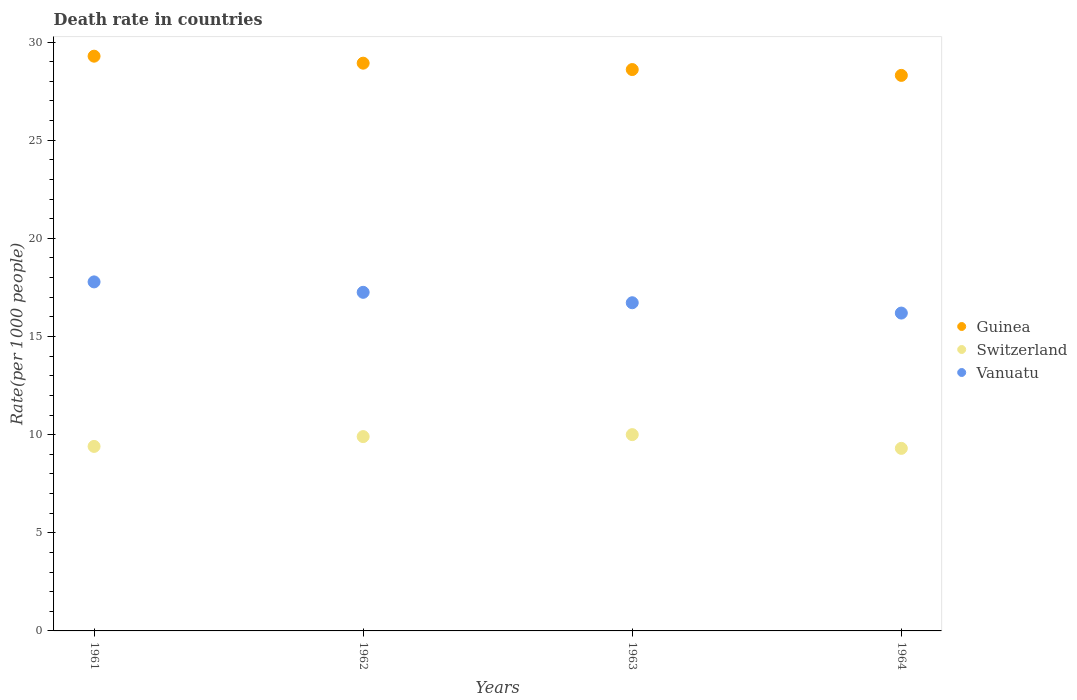How many different coloured dotlines are there?
Your answer should be very brief. 3. Is the number of dotlines equal to the number of legend labels?
Offer a very short reply. Yes. What is the death rate in Guinea in 1963?
Offer a terse response. 28.6. Across all years, what is the maximum death rate in Switzerland?
Your answer should be very brief. 10. Across all years, what is the minimum death rate in Guinea?
Your response must be concise. 28.3. In which year was the death rate in Vanuatu minimum?
Ensure brevity in your answer.  1964. What is the total death rate in Vanuatu in the graph?
Provide a succinct answer. 67.94. What is the difference between the death rate in Switzerland in 1961 and that in 1962?
Make the answer very short. -0.5. What is the difference between the death rate in Vanuatu in 1961 and the death rate in Switzerland in 1963?
Your answer should be very brief. 7.78. What is the average death rate in Guinea per year?
Make the answer very short. 28.78. In the year 1962, what is the difference between the death rate in Guinea and death rate in Vanuatu?
Offer a terse response. 11.67. In how many years, is the death rate in Guinea greater than 3?
Offer a very short reply. 4. What is the ratio of the death rate in Vanuatu in 1961 to that in 1964?
Provide a short and direct response. 1.1. Is the difference between the death rate in Guinea in 1961 and 1964 greater than the difference between the death rate in Vanuatu in 1961 and 1964?
Your response must be concise. No. What is the difference between the highest and the second highest death rate in Switzerland?
Ensure brevity in your answer.  0.1. What is the difference between the highest and the lowest death rate in Vanuatu?
Provide a succinct answer. 1.59. Is it the case that in every year, the sum of the death rate in Vanuatu and death rate in Switzerland  is greater than the death rate in Guinea?
Keep it short and to the point. No. Is the death rate in Guinea strictly less than the death rate in Vanuatu over the years?
Offer a terse response. No. How many years are there in the graph?
Give a very brief answer. 4. Are the values on the major ticks of Y-axis written in scientific E-notation?
Ensure brevity in your answer.  No. Does the graph contain any zero values?
Give a very brief answer. No. How many legend labels are there?
Give a very brief answer. 3. What is the title of the graph?
Ensure brevity in your answer.  Death rate in countries. What is the label or title of the Y-axis?
Offer a terse response. Rate(per 1000 people). What is the Rate(per 1000 people) of Guinea in 1961?
Your answer should be very brief. 29.28. What is the Rate(per 1000 people) of Vanuatu in 1961?
Provide a succinct answer. 17.78. What is the Rate(per 1000 people) of Guinea in 1962?
Offer a very short reply. 28.92. What is the Rate(per 1000 people) in Vanuatu in 1962?
Ensure brevity in your answer.  17.25. What is the Rate(per 1000 people) of Guinea in 1963?
Your answer should be compact. 28.6. What is the Rate(per 1000 people) of Switzerland in 1963?
Ensure brevity in your answer.  10. What is the Rate(per 1000 people) of Vanuatu in 1963?
Give a very brief answer. 16.72. What is the Rate(per 1000 people) in Guinea in 1964?
Your answer should be very brief. 28.3. What is the Rate(per 1000 people) of Vanuatu in 1964?
Offer a very short reply. 16.19. Across all years, what is the maximum Rate(per 1000 people) of Guinea?
Ensure brevity in your answer.  29.28. Across all years, what is the maximum Rate(per 1000 people) in Vanuatu?
Your answer should be compact. 17.78. Across all years, what is the minimum Rate(per 1000 people) in Guinea?
Offer a terse response. 28.3. Across all years, what is the minimum Rate(per 1000 people) of Vanuatu?
Offer a very short reply. 16.19. What is the total Rate(per 1000 people) in Guinea in the graph?
Your answer should be compact. 115.11. What is the total Rate(per 1000 people) in Switzerland in the graph?
Offer a terse response. 38.6. What is the total Rate(per 1000 people) in Vanuatu in the graph?
Your response must be concise. 67.94. What is the difference between the Rate(per 1000 people) in Guinea in 1961 and that in 1962?
Ensure brevity in your answer.  0.36. What is the difference between the Rate(per 1000 people) in Vanuatu in 1961 and that in 1962?
Your answer should be compact. 0.53. What is the difference between the Rate(per 1000 people) in Guinea in 1961 and that in 1963?
Provide a short and direct response. 0.68. What is the difference between the Rate(per 1000 people) of Vanuatu in 1961 and that in 1963?
Give a very brief answer. 1.06. What is the difference between the Rate(per 1000 people) in Guinea in 1961 and that in 1964?
Offer a very short reply. 0.98. What is the difference between the Rate(per 1000 people) in Switzerland in 1961 and that in 1964?
Offer a terse response. 0.1. What is the difference between the Rate(per 1000 people) in Vanuatu in 1961 and that in 1964?
Your response must be concise. 1.59. What is the difference between the Rate(per 1000 people) of Guinea in 1962 and that in 1963?
Offer a terse response. 0.33. What is the difference between the Rate(per 1000 people) of Vanuatu in 1962 and that in 1963?
Offer a terse response. 0.53. What is the difference between the Rate(per 1000 people) of Guinea in 1962 and that in 1964?
Provide a short and direct response. 0.62. What is the difference between the Rate(per 1000 people) in Vanuatu in 1962 and that in 1964?
Keep it short and to the point. 1.06. What is the difference between the Rate(per 1000 people) of Guinea in 1963 and that in 1964?
Make the answer very short. 0.3. What is the difference between the Rate(per 1000 people) of Vanuatu in 1963 and that in 1964?
Give a very brief answer. 0.53. What is the difference between the Rate(per 1000 people) of Guinea in 1961 and the Rate(per 1000 people) of Switzerland in 1962?
Give a very brief answer. 19.38. What is the difference between the Rate(per 1000 people) of Guinea in 1961 and the Rate(per 1000 people) of Vanuatu in 1962?
Ensure brevity in your answer.  12.03. What is the difference between the Rate(per 1000 people) of Switzerland in 1961 and the Rate(per 1000 people) of Vanuatu in 1962?
Provide a short and direct response. -7.85. What is the difference between the Rate(per 1000 people) of Guinea in 1961 and the Rate(per 1000 people) of Switzerland in 1963?
Your response must be concise. 19.28. What is the difference between the Rate(per 1000 people) of Guinea in 1961 and the Rate(per 1000 people) of Vanuatu in 1963?
Your answer should be very brief. 12.56. What is the difference between the Rate(per 1000 people) in Switzerland in 1961 and the Rate(per 1000 people) in Vanuatu in 1963?
Offer a very short reply. -7.32. What is the difference between the Rate(per 1000 people) of Guinea in 1961 and the Rate(per 1000 people) of Switzerland in 1964?
Provide a short and direct response. 19.98. What is the difference between the Rate(per 1000 people) of Guinea in 1961 and the Rate(per 1000 people) of Vanuatu in 1964?
Provide a short and direct response. 13.09. What is the difference between the Rate(per 1000 people) of Switzerland in 1961 and the Rate(per 1000 people) of Vanuatu in 1964?
Keep it short and to the point. -6.79. What is the difference between the Rate(per 1000 people) of Guinea in 1962 and the Rate(per 1000 people) of Switzerland in 1963?
Make the answer very short. 18.92. What is the difference between the Rate(per 1000 people) of Guinea in 1962 and the Rate(per 1000 people) of Vanuatu in 1963?
Your answer should be compact. 12.21. What is the difference between the Rate(per 1000 people) in Switzerland in 1962 and the Rate(per 1000 people) in Vanuatu in 1963?
Make the answer very short. -6.82. What is the difference between the Rate(per 1000 people) of Guinea in 1962 and the Rate(per 1000 people) of Switzerland in 1964?
Provide a succinct answer. 19.62. What is the difference between the Rate(per 1000 people) of Guinea in 1962 and the Rate(per 1000 people) of Vanuatu in 1964?
Keep it short and to the point. 12.73. What is the difference between the Rate(per 1000 people) of Switzerland in 1962 and the Rate(per 1000 people) of Vanuatu in 1964?
Give a very brief answer. -6.29. What is the difference between the Rate(per 1000 people) in Guinea in 1963 and the Rate(per 1000 people) in Switzerland in 1964?
Your answer should be very brief. 19.3. What is the difference between the Rate(per 1000 people) of Guinea in 1963 and the Rate(per 1000 people) of Vanuatu in 1964?
Ensure brevity in your answer.  12.41. What is the difference between the Rate(per 1000 people) of Switzerland in 1963 and the Rate(per 1000 people) of Vanuatu in 1964?
Give a very brief answer. -6.19. What is the average Rate(per 1000 people) of Guinea per year?
Give a very brief answer. 28.78. What is the average Rate(per 1000 people) of Switzerland per year?
Offer a terse response. 9.65. What is the average Rate(per 1000 people) in Vanuatu per year?
Give a very brief answer. 16.99. In the year 1961, what is the difference between the Rate(per 1000 people) of Guinea and Rate(per 1000 people) of Switzerland?
Make the answer very short. 19.88. In the year 1961, what is the difference between the Rate(per 1000 people) of Guinea and Rate(per 1000 people) of Vanuatu?
Offer a terse response. 11.5. In the year 1961, what is the difference between the Rate(per 1000 people) of Switzerland and Rate(per 1000 people) of Vanuatu?
Keep it short and to the point. -8.38. In the year 1962, what is the difference between the Rate(per 1000 people) in Guinea and Rate(per 1000 people) in Switzerland?
Your answer should be very brief. 19.02. In the year 1962, what is the difference between the Rate(per 1000 people) in Guinea and Rate(per 1000 people) in Vanuatu?
Provide a succinct answer. 11.67. In the year 1962, what is the difference between the Rate(per 1000 people) in Switzerland and Rate(per 1000 people) in Vanuatu?
Your answer should be very brief. -7.35. In the year 1963, what is the difference between the Rate(per 1000 people) of Guinea and Rate(per 1000 people) of Switzerland?
Your response must be concise. 18.6. In the year 1963, what is the difference between the Rate(per 1000 people) of Guinea and Rate(per 1000 people) of Vanuatu?
Make the answer very short. 11.88. In the year 1963, what is the difference between the Rate(per 1000 people) of Switzerland and Rate(per 1000 people) of Vanuatu?
Give a very brief answer. -6.72. In the year 1964, what is the difference between the Rate(per 1000 people) of Guinea and Rate(per 1000 people) of Switzerland?
Your answer should be very brief. 19. In the year 1964, what is the difference between the Rate(per 1000 people) in Guinea and Rate(per 1000 people) in Vanuatu?
Ensure brevity in your answer.  12.11. In the year 1964, what is the difference between the Rate(per 1000 people) in Switzerland and Rate(per 1000 people) in Vanuatu?
Make the answer very short. -6.89. What is the ratio of the Rate(per 1000 people) in Guinea in 1961 to that in 1962?
Offer a very short reply. 1.01. What is the ratio of the Rate(per 1000 people) of Switzerland in 1961 to that in 1962?
Provide a short and direct response. 0.95. What is the ratio of the Rate(per 1000 people) in Vanuatu in 1961 to that in 1962?
Your response must be concise. 1.03. What is the ratio of the Rate(per 1000 people) of Guinea in 1961 to that in 1963?
Your answer should be compact. 1.02. What is the ratio of the Rate(per 1000 people) of Vanuatu in 1961 to that in 1963?
Offer a terse response. 1.06. What is the ratio of the Rate(per 1000 people) of Guinea in 1961 to that in 1964?
Provide a succinct answer. 1.03. What is the ratio of the Rate(per 1000 people) in Switzerland in 1961 to that in 1964?
Your answer should be very brief. 1.01. What is the ratio of the Rate(per 1000 people) in Vanuatu in 1961 to that in 1964?
Your response must be concise. 1.1. What is the ratio of the Rate(per 1000 people) of Guinea in 1962 to that in 1963?
Ensure brevity in your answer.  1.01. What is the ratio of the Rate(per 1000 people) in Vanuatu in 1962 to that in 1963?
Your response must be concise. 1.03. What is the ratio of the Rate(per 1000 people) in Guinea in 1962 to that in 1964?
Provide a short and direct response. 1.02. What is the ratio of the Rate(per 1000 people) in Switzerland in 1962 to that in 1964?
Offer a very short reply. 1.06. What is the ratio of the Rate(per 1000 people) of Vanuatu in 1962 to that in 1964?
Provide a short and direct response. 1.07. What is the ratio of the Rate(per 1000 people) in Guinea in 1963 to that in 1964?
Keep it short and to the point. 1.01. What is the ratio of the Rate(per 1000 people) in Switzerland in 1963 to that in 1964?
Give a very brief answer. 1.08. What is the ratio of the Rate(per 1000 people) of Vanuatu in 1963 to that in 1964?
Offer a very short reply. 1.03. What is the difference between the highest and the second highest Rate(per 1000 people) in Guinea?
Your answer should be very brief. 0.36. What is the difference between the highest and the second highest Rate(per 1000 people) in Vanuatu?
Offer a terse response. 0.53. What is the difference between the highest and the lowest Rate(per 1000 people) in Vanuatu?
Your response must be concise. 1.59. 